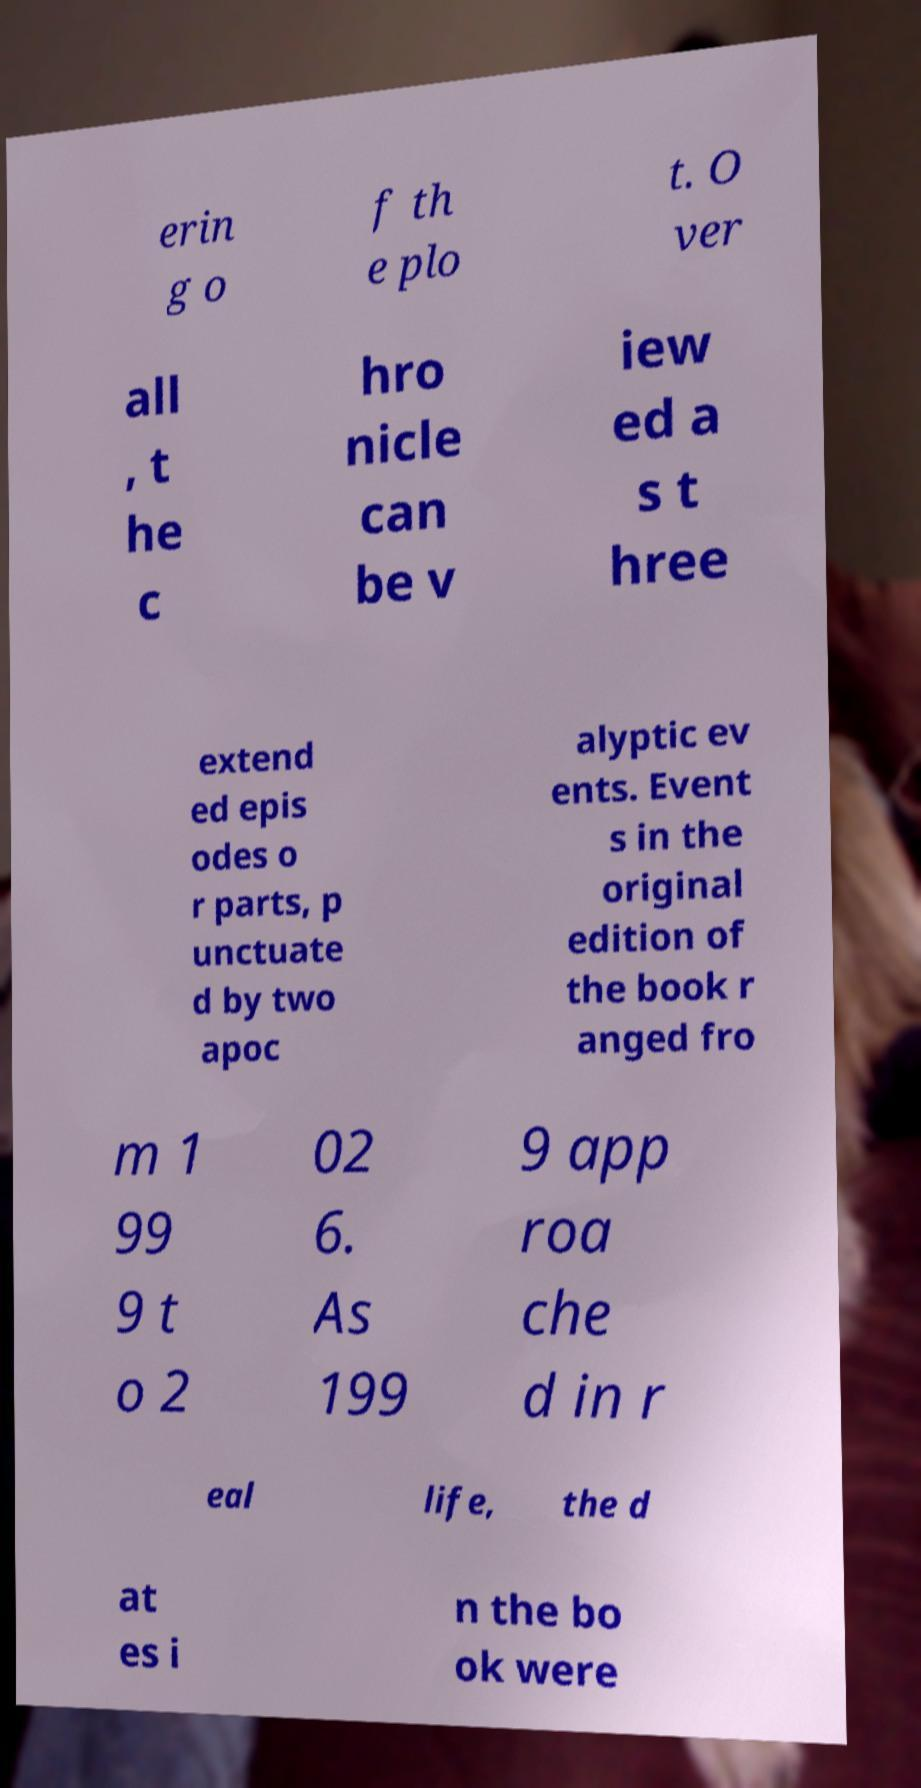For documentation purposes, I need the text within this image transcribed. Could you provide that? erin g o f th e plo t. O ver all , t he c hro nicle can be v iew ed a s t hree extend ed epis odes o r parts, p unctuate d by two apoc alyptic ev ents. Event s in the original edition of the book r anged fro m 1 99 9 t o 2 02 6. As 199 9 app roa che d in r eal life, the d at es i n the bo ok were 